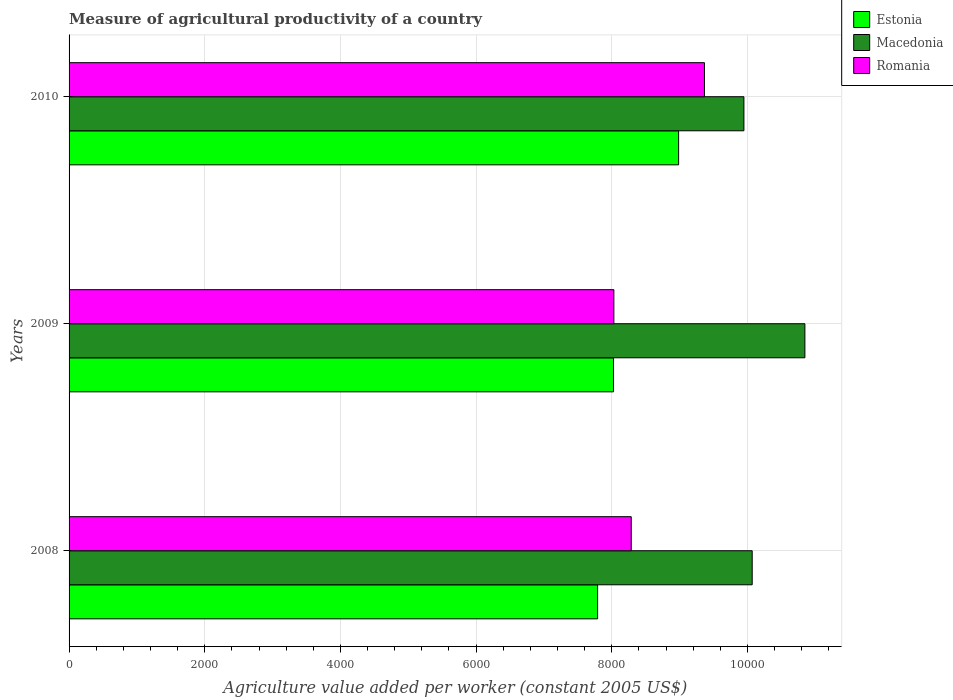How many different coloured bars are there?
Provide a succinct answer. 3. How many groups of bars are there?
Your answer should be very brief. 3. How many bars are there on the 1st tick from the top?
Give a very brief answer. 3. How many bars are there on the 3rd tick from the bottom?
Your answer should be very brief. 3. What is the label of the 3rd group of bars from the top?
Offer a very short reply. 2008. What is the measure of agricultural productivity in Estonia in 2008?
Provide a short and direct response. 7790.97. Across all years, what is the maximum measure of agricultural productivity in Estonia?
Make the answer very short. 8984.84. Across all years, what is the minimum measure of agricultural productivity in Macedonia?
Offer a very short reply. 9947.45. In which year was the measure of agricultural productivity in Estonia maximum?
Give a very brief answer. 2010. What is the total measure of agricultural productivity in Romania in the graph?
Offer a terse response. 2.57e+04. What is the difference between the measure of agricultural productivity in Macedonia in 2008 and that in 2010?
Ensure brevity in your answer.  122.11. What is the difference between the measure of agricultural productivity in Macedonia in 2009 and the measure of agricultural productivity in Romania in 2008?
Offer a very short reply. 2559.78. What is the average measure of agricultural productivity in Romania per year?
Give a very brief answer. 8560.99. In the year 2008, what is the difference between the measure of agricultural productivity in Estonia and measure of agricultural productivity in Macedonia?
Give a very brief answer. -2278.58. What is the ratio of the measure of agricultural productivity in Estonia in 2008 to that in 2010?
Make the answer very short. 0.87. What is the difference between the highest and the second highest measure of agricultural productivity in Macedonia?
Offer a terse response. 776.71. What is the difference between the highest and the lowest measure of agricultural productivity in Estonia?
Make the answer very short. 1193.87. In how many years, is the measure of agricultural productivity in Macedonia greater than the average measure of agricultural productivity in Macedonia taken over all years?
Provide a short and direct response. 1. What does the 2nd bar from the top in 2010 represents?
Offer a very short reply. Macedonia. What does the 2nd bar from the bottom in 2010 represents?
Give a very brief answer. Macedonia. Is it the case that in every year, the sum of the measure of agricultural productivity in Estonia and measure of agricultural productivity in Romania is greater than the measure of agricultural productivity in Macedonia?
Ensure brevity in your answer.  Yes. How many years are there in the graph?
Your answer should be compact. 3. What is the difference between two consecutive major ticks on the X-axis?
Give a very brief answer. 2000. Are the values on the major ticks of X-axis written in scientific E-notation?
Offer a terse response. No. Does the graph contain any zero values?
Provide a short and direct response. No. Does the graph contain grids?
Your answer should be very brief. Yes. Where does the legend appear in the graph?
Provide a short and direct response. Top right. How many legend labels are there?
Ensure brevity in your answer.  3. How are the legend labels stacked?
Offer a terse response. Vertical. What is the title of the graph?
Your answer should be compact. Measure of agricultural productivity of a country. What is the label or title of the X-axis?
Provide a succinct answer. Agriculture value added per worker (constant 2005 US$). What is the label or title of the Y-axis?
Keep it short and to the point. Years. What is the Agriculture value added per worker (constant 2005 US$) of Estonia in 2008?
Ensure brevity in your answer.  7790.97. What is the Agriculture value added per worker (constant 2005 US$) of Macedonia in 2008?
Your response must be concise. 1.01e+04. What is the Agriculture value added per worker (constant 2005 US$) in Romania in 2008?
Offer a very short reply. 8286.48. What is the Agriculture value added per worker (constant 2005 US$) of Estonia in 2009?
Provide a short and direct response. 8024.87. What is the Agriculture value added per worker (constant 2005 US$) in Macedonia in 2009?
Your answer should be very brief. 1.08e+04. What is the Agriculture value added per worker (constant 2005 US$) of Romania in 2009?
Your response must be concise. 8030.5. What is the Agriculture value added per worker (constant 2005 US$) of Estonia in 2010?
Offer a very short reply. 8984.84. What is the Agriculture value added per worker (constant 2005 US$) of Macedonia in 2010?
Provide a short and direct response. 9947.45. What is the Agriculture value added per worker (constant 2005 US$) in Romania in 2010?
Your answer should be compact. 9365.97. Across all years, what is the maximum Agriculture value added per worker (constant 2005 US$) in Estonia?
Offer a terse response. 8984.84. Across all years, what is the maximum Agriculture value added per worker (constant 2005 US$) in Macedonia?
Your response must be concise. 1.08e+04. Across all years, what is the maximum Agriculture value added per worker (constant 2005 US$) of Romania?
Make the answer very short. 9365.97. Across all years, what is the minimum Agriculture value added per worker (constant 2005 US$) of Estonia?
Your response must be concise. 7790.97. Across all years, what is the minimum Agriculture value added per worker (constant 2005 US$) in Macedonia?
Ensure brevity in your answer.  9947.45. Across all years, what is the minimum Agriculture value added per worker (constant 2005 US$) of Romania?
Your answer should be very brief. 8030.5. What is the total Agriculture value added per worker (constant 2005 US$) in Estonia in the graph?
Offer a terse response. 2.48e+04. What is the total Agriculture value added per worker (constant 2005 US$) of Macedonia in the graph?
Your answer should be very brief. 3.09e+04. What is the total Agriculture value added per worker (constant 2005 US$) in Romania in the graph?
Make the answer very short. 2.57e+04. What is the difference between the Agriculture value added per worker (constant 2005 US$) in Estonia in 2008 and that in 2009?
Give a very brief answer. -233.9. What is the difference between the Agriculture value added per worker (constant 2005 US$) in Macedonia in 2008 and that in 2009?
Ensure brevity in your answer.  -776.71. What is the difference between the Agriculture value added per worker (constant 2005 US$) of Romania in 2008 and that in 2009?
Your response must be concise. 255.98. What is the difference between the Agriculture value added per worker (constant 2005 US$) in Estonia in 2008 and that in 2010?
Provide a short and direct response. -1193.87. What is the difference between the Agriculture value added per worker (constant 2005 US$) in Macedonia in 2008 and that in 2010?
Your answer should be very brief. 122.11. What is the difference between the Agriculture value added per worker (constant 2005 US$) in Romania in 2008 and that in 2010?
Provide a short and direct response. -1079.49. What is the difference between the Agriculture value added per worker (constant 2005 US$) of Estonia in 2009 and that in 2010?
Offer a terse response. -959.96. What is the difference between the Agriculture value added per worker (constant 2005 US$) of Macedonia in 2009 and that in 2010?
Your response must be concise. 898.81. What is the difference between the Agriculture value added per worker (constant 2005 US$) of Romania in 2009 and that in 2010?
Ensure brevity in your answer.  -1335.47. What is the difference between the Agriculture value added per worker (constant 2005 US$) of Estonia in 2008 and the Agriculture value added per worker (constant 2005 US$) of Macedonia in 2009?
Your answer should be very brief. -3055.29. What is the difference between the Agriculture value added per worker (constant 2005 US$) of Estonia in 2008 and the Agriculture value added per worker (constant 2005 US$) of Romania in 2009?
Your answer should be compact. -239.53. What is the difference between the Agriculture value added per worker (constant 2005 US$) in Macedonia in 2008 and the Agriculture value added per worker (constant 2005 US$) in Romania in 2009?
Your answer should be very brief. 2039.05. What is the difference between the Agriculture value added per worker (constant 2005 US$) in Estonia in 2008 and the Agriculture value added per worker (constant 2005 US$) in Macedonia in 2010?
Give a very brief answer. -2156.48. What is the difference between the Agriculture value added per worker (constant 2005 US$) of Estonia in 2008 and the Agriculture value added per worker (constant 2005 US$) of Romania in 2010?
Your answer should be very brief. -1575. What is the difference between the Agriculture value added per worker (constant 2005 US$) in Macedonia in 2008 and the Agriculture value added per worker (constant 2005 US$) in Romania in 2010?
Ensure brevity in your answer.  703.59. What is the difference between the Agriculture value added per worker (constant 2005 US$) of Estonia in 2009 and the Agriculture value added per worker (constant 2005 US$) of Macedonia in 2010?
Your response must be concise. -1922.58. What is the difference between the Agriculture value added per worker (constant 2005 US$) of Estonia in 2009 and the Agriculture value added per worker (constant 2005 US$) of Romania in 2010?
Provide a short and direct response. -1341.1. What is the difference between the Agriculture value added per worker (constant 2005 US$) of Macedonia in 2009 and the Agriculture value added per worker (constant 2005 US$) of Romania in 2010?
Ensure brevity in your answer.  1480.29. What is the average Agriculture value added per worker (constant 2005 US$) in Estonia per year?
Make the answer very short. 8266.9. What is the average Agriculture value added per worker (constant 2005 US$) of Macedonia per year?
Offer a very short reply. 1.03e+04. What is the average Agriculture value added per worker (constant 2005 US$) of Romania per year?
Offer a very short reply. 8560.99. In the year 2008, what is the difference between the Agriculture value added per worker (constant 2005 US$) of Estonia and Agriculture value added per worker (constant 2005 US$) of Macedonia?
Ensure brevity in your answer.  -2278.59. In the year 2008, what is the difference between the Agriculture value added per worker (constant 2005 US$) in Estonia and Agriculture value added per worker (constant 2005 US$) in Romania?
Your answer should be very brief. -495.51. In the year 2008, what is the difference between the Agriculture value added per worker (constant 2005 US$) in Macedonia and Agriculture value added per worker (constant 2005 US$) in Romania?
Ensure brevity in your answer.  1783.08. In the year 2009, what is the difference between the Agriculture value added per worker (constant 2005 US$) of Estonia and Agriculture value added per worker (constant 2005 US$) of Macedonia?
Your response must be concise. -2821.39. In the year 2009, what is the difference between the Agriculture value added per worker (constant 2005 US$) in Estonia and Agriculture value added per worker (constant 2005 US$) in Romania?
Ensure brevity in your answer.  -5.63. In the year 2009, what is the difference between the Agriculture value added per worker (constant 2005 US$) in Macedonia and Agriculture value added per worker (constant 2005 US$) in Romania?
Offer a terse response. 2815.76. In the year 2010, what is the difference between the Agriculture value added per worker (constant 2005 US$) in Estonia and Agriculture value added per worker (constant 2005 US$) in Macedonia?
Your answer should be very brief. -962.61. In the year 2010, what is the difference between the Agriculture value added per worker (constant 2005 US$) of Estonia and Agriculture value added per worker (constant 2005 US$) of Romania?
Make the answer very short. -381.13. In the year 2010, what is the difference between the Agriculture value added per worker (constant 2005 US$) of Macedonia and Agriculture value added per worker (constant 2005 US$) of Romania?
Offer a terse response. 581.48. What is the ratio of the Agriculture value added per worker (constant 2005 US$) in Estonia in 2008 to that in 2009?
Provide a short and direct response. 0.97. What is the ratio of the Agriculture value added per worker (constant 2005 US$) of Macedonia in 2008 to that in 2009?
Make the answer very short. 0.93. What is the ratio of the Agriculture value added per worker (constant 2005 US$) in Romania in 2008 to that in 2009?
Offer a very short reply. 1.03. What is the ratio of the Agriculture value added per worker (constant 2005 US$) of Estonia in 2008 to that in 2010?
Your answer should be very brief. 0.87. What is the ratio of the Agriculture value added per worker (constant 2005 US$) of Macedonia in 2008 to that in 2010?
Offer a terse response. 1.01. What is the ratio of the Agriculture value added per worker (constant 2005 US$) of Romania in 2008 to that in 2010?
Keep it short and to the point. 0.88. What is the ratio of the Agriculture value added per worker (constant 2005 US$) in Estonia in 2009 to that in 2010?
Your answer should be very brief. 0.89. What is the ratio of the Agriculture value added per worker (constant 2005 US$) in Macedonia in 2009 to that in 2010?
Give a very brief answer. 1.09. What is the ratio of the Agriculture value added per worker (constant 2005 US$) in Romania in 2009 to that in 2010?
Your answer should be very brief. 0.86. What is the difference between the highest and the second highest Agriculture value added per worker (constant 2005 US$) in Estonia?
Your response must be concise. 959.96. What is the difference between the highest and the second highest Agriculture value added per worker (constant 2005 US$) of Macedonia?
Offer a very short reply. 776.71. What is the difference between the highest and the second highest Agriculture value added per worker (constant 2005 US$) in Romania?
Offer a very short reply. 1079.49. What is the difference between the highest and the lowest Agriculture value added per worker (constant 2005 US$) in Estonia?
Your answer should be very brief. 1193.87. What is the difference between the highest and the lowest Agriculture value added per worker (constant 2005 US$) in Macedonia?
Your answer should be compact. 898.81. What is the difference between the highest and the lowest Agriculture value added per worker (constant 2005 US$) of Romania?
Your answer should be very brief. 1335.47. 